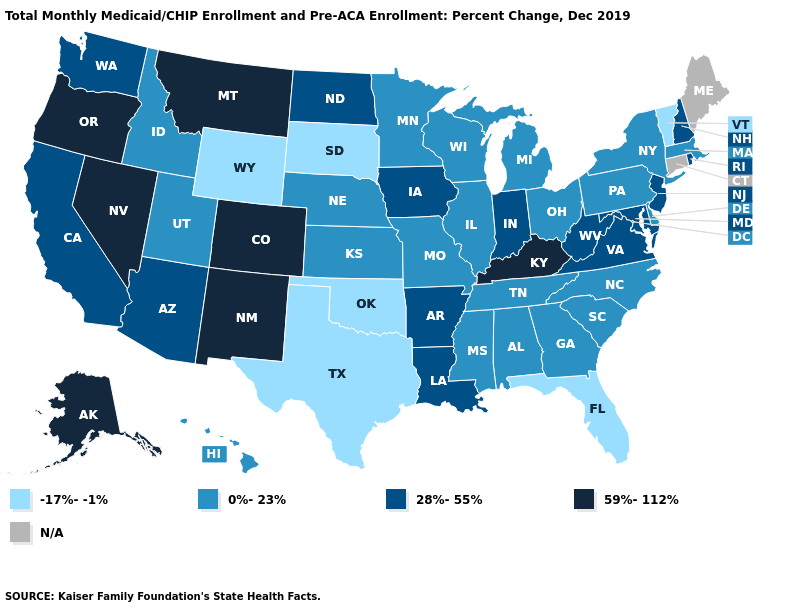What is the value of Minnesota?
Be succinct. 0%-23%. What is the value of South Carolina?
Write a very short answer. 0%-23%. Which states have the lowest value in the USA?
Keep it brief. Florida, Oklahoma, South Dakota, Texas, Vermont, Wyoming. What is the lowest value in states that border Indiana?
Be succinct. 0%-23%. What is the value of Wyoming?
Be succinct. -17%--1%. What is the highest value in the MidWest ?
Keep it brief. 28%-55%. Which states have the highest value in the USA?
Give a very brief answer. Alaska, Colorado, Kentucky, Montana, Nevada, New Mexico, Oregon. What is the highest value in the USA?
Write a very short answer. 59%-112%. Name the states that have a value in the range 59%-112%?
Answer briefly. Alaska, Colorado, Kentucky, Montana, Nevada, New Mexico, Oregon. Among the states that border New York , does New Jersey have the highest value?
Concise answer only. Yes. What is the value of Arkansas?
Short answer required. 28%-55%. What is the lowest value in the Northeast?
Write a very short answer. -17%--1%. What is the value of Indiana?
Short answer required. 28%-55%. Name the states that have a value in the range 0%-23%?
Quick response, please. Alabama, Delaware, Georgia, Hawaii, Idaho, Illinois, Kansas, Massachusetts, Michigan, Minnesota, Mississippi, Missouri, Nebraska, New York, North Carolina, Ohio, Pennsylvania, South Carolina, Tennessee, Utah, Wisconsin. 